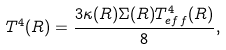Convert formula to latex. <formula><loc_0><loc_0><loc_500><loc_500>T ^ { 4 } ( R ) = \frac { 3 \kappa ( R ) \Sigma ( R ) T ^ { 4 } _ { e f f } ( R ) } { 8 } ,</formula> 